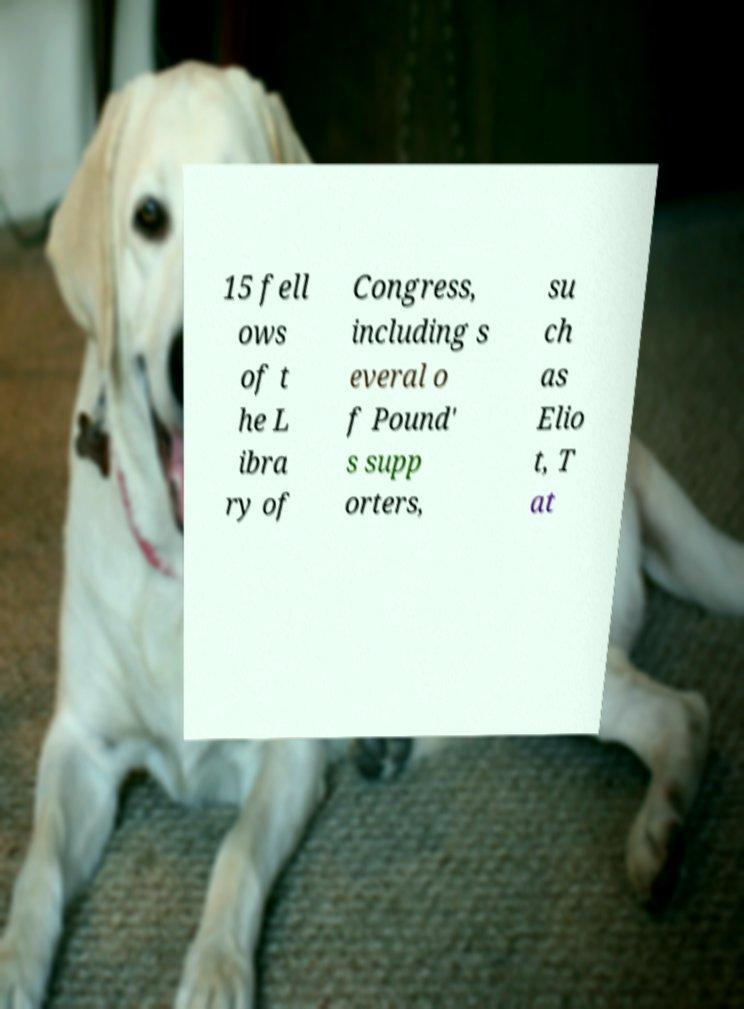Please read and relay the text visible in this image. What does it say? 15 fell ows of t he L ibra ry of Congress, including s everal o f Pound' s supp orters, su ch as Elio t, T at 